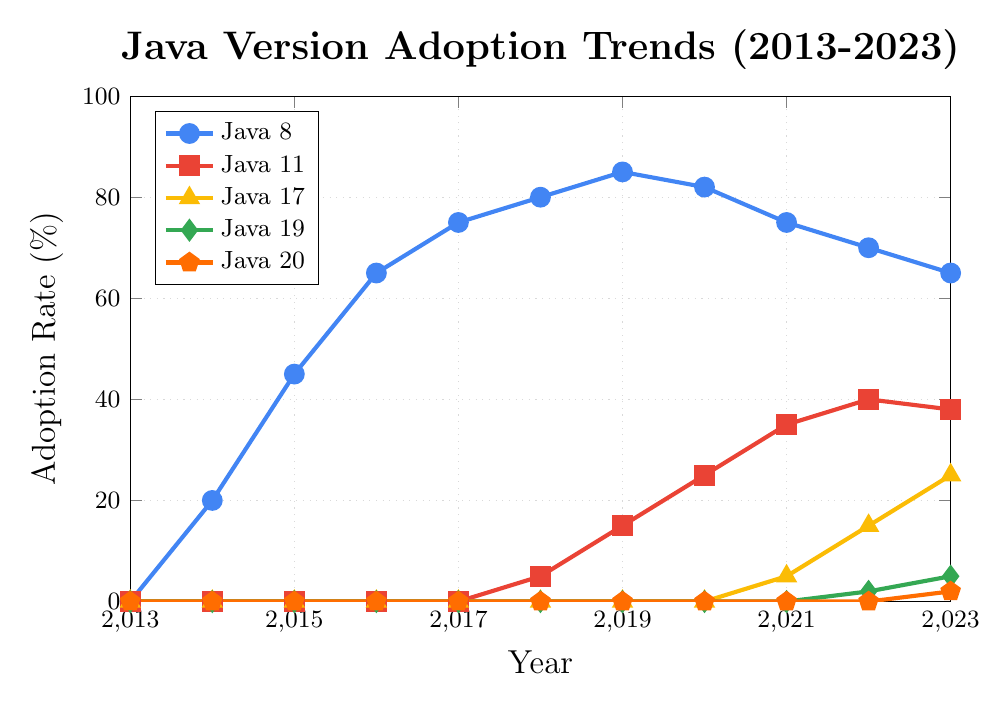What was the adoption rate of Java 8 in 2017? Look at the specific data point for Java 8 in the year 2017 on the chart.
Answer: 75% Which Java version showed the most significant growth in adoption between 2018 and 2020? Compare the adoption rates for all the Java versions in 2018 and 2020, and determine which had the greatest increase. Java 11 grew from 5% to 25%, an increase of 20%.
Answer: Java 11 By how much did the adoption rate of Java 8 decline from its peak in 2019 to 2023? Identify the peak adoption rate, which is 85% in 2019. Subtract the 2023 rate, 65%, from the peak rate.
Answer: 20% At what year did Java 17 first appear on the chart, and what was its adoption rate that year? Look at the points for Java 17 and find the first non-zero value, which is in 2021.
Answer: 2021, 5% Compare the adoption rates of Java 19 and Java 20 in 2023. Which version has a higher rate and by how much? Look at the 2023 adoption rates for Java 19 (5%) and Java 20 (2%). Java 19 has a higher rate. Subtract the rate of Java 20 from Java 19.
Answer: Java 19 by 3% What was the trend in the adoption rate of Java 8 from 2014 to 2018, and what does this indicate? Examine the line for Java 8 from 2014 to 2018, noting that it increased from 20% to 80%.
Answer: Increasing trend In which year did Java 11 surpass the 20% adoption rate? Find the first year where the adoption rate for Java 11 exceeds 20% on the chart, which is in 2020.
Answer: 2020 What is the difference between the adoption rates of Java 11 and Java 8 in 2023? Note the adoption rates for Java 11 (38%) and Java 8 (65%) in 2023. Subtract Java 11's rate from Java 8's rate.
Answer: 27% Which Java version showed any increase in adoption rate every subsequent year since its introduction? Examine each Java version's line and determine if there is a continuous increase. Java 11 fits this description.
Answer: Java 11 By what percentage did the adoption rate of Java 20 increase in 2023 compared to 2022? Determine the adoption rates for Java 20 in 2022 (0%) and 2023 (2%). Subtract the 2022 rate from the 2023 rate, resulting in a 2% increase.
Answer: 2% 